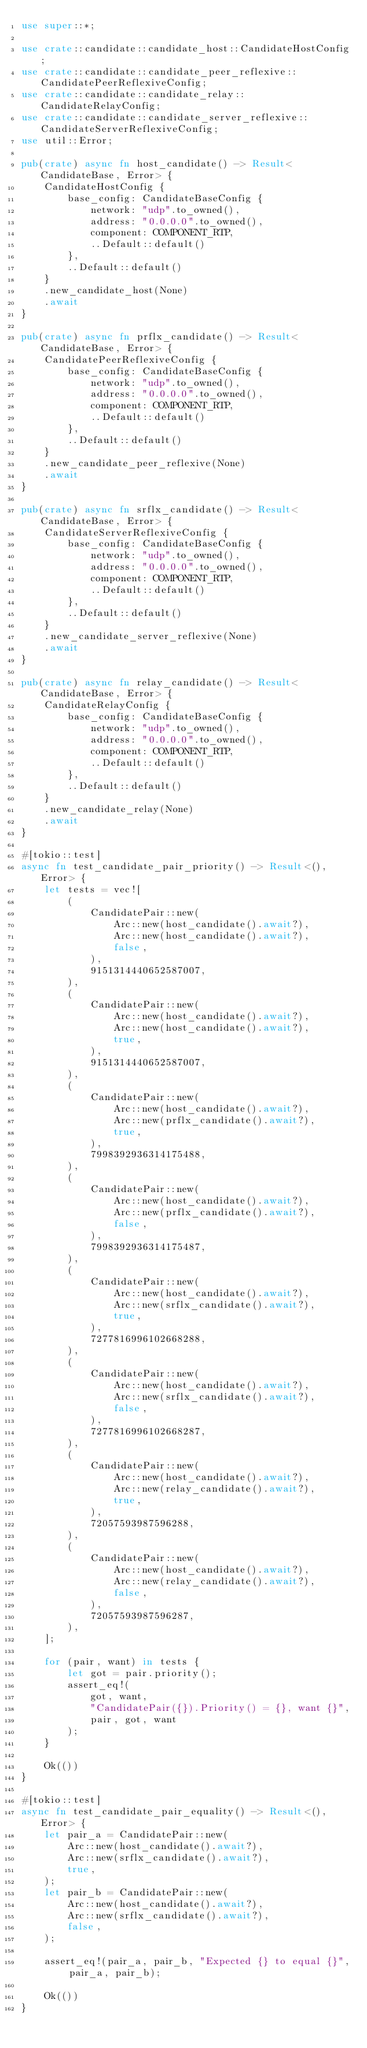<code> <loc_0><loc_0><loc_500><loc_500><_Rust_>use super::*;

use crate::candidate::candidate_host::CandidateHostConfig;
use crate::candidate::candidate_peer_reflexive::CandidatePeerReflexiveConfig;
use crate::candidate::candidate_relay::CandidateRelayConfig;
use crate::candidate::candidate_server_reflexive::CandidateServerReflexiveConfig;
use util::Error;

pub(crate) async fn host_candidate() -> Result<CandidateBase, Error> {
    CandidateHostConfig {
        base_config: CandidateBaseConfig {
            network: "udp".to_owned(),
            address: "0.0.0.0".to_owned(),
            component: COMPONENT_RTP,
            ..Default::default()
        },
        ..Default::default()
    }
    .new_candidate_host(None)
    .await
}

pub(crate) async fn prflx_candidate() -> Result<CandidateBase, Error> {
    CandidatePeerReflexiveConfig {
        base_config: CandidateBaseConfig {
            network: "udp".to_owned(),
            address: "0.0.0.0".to_owned(),
            component: COMPONENT_RTP,
            ..Default::default()
        },
        ..Default::default()
    }
    .new_candidate_peer_reflexive(None)
    .await
}

pub(crate) async fn srflx_candidate() -> Result<CandidateBase, Error> {
    CandidateServerReflexiveConfig {
        base_config: CandidateBaseConfig {
            network: "udp".to_owned(),
            address: "0.0.0.0".to_owned(),
            component: COMPONENT_RTP,
            ..Default::default()
        },
        ..Default::default()
    }
    .new_candidate_server_reflexive(None)
    .await
}

pub(crate) async fn relay_candidate() -> Result<CandidateBase, Error> {
    CandidateRelayConfig {
        base_config: CandidateBaseConfig {
            network: "udp".to_owned(),
            address: "0.0.0.0".to_owned(),
            component: COMPONENT_RTP,
            ..Default::default()
        },
        ..Default::default()
    }
    .new_candidate_relay(None)
    .await
}

#[tokio::test]
async fn test_candidate_pair_priority() -> Result<(), Error> {
    let tests = vec![
        (
            CandidatePair::new(
                Arc::new(host_candidate().await?),
                Arc::new(host_candidate().await?),
                false,
            ),
            9151314440652587007,
        ),
        (
            CandidatePair::new(
                Arc::new(host_candidate().await?),
                Arc::new(host_candidate().await?),
                true,
            ),
            9151314440652587007,
        ),
        (
            CandidatePair::new(
                Arc::new(host_candidate().await?),
                Arc::new(prflx_candidate().await?),
                true,
            ),
            7998392936314175488,
        ),
        (
            CandidatePair::new(
                Arc::new(host_candidate().await?),
                Arc::new(prflx_candidate().await?),
                false,
            ),
            7998392936314175487,
        ),
        (
            CandidatePair::new(
                Arc::new(host_candidate().await?),
                Arc::new(srflx_candidate().await?),
                true,
            ),
            7277816996102668288,
        ),
        (
            CandidatePair::new(
                Arc::new(host_candidate().await?),
                Arc::new(srflx_candidate().await?),
                false,
            ),
            7277816996102668287,
        ),
        (
            CandidatePair::new(
                Arc::new(host_candidate().await?),
                Arc::new(relay_candidate().await?),
                true,
            ),
            72057593987596288,
        ),
        (
            CandidatePair::new(
                Arc::new(host_candidate().await?),
                Arc::new(relay_candidate().await?),
                false,
            ),
            72057593987596287,
        ),
    ];

    for (pair, want) in tests {
        let got = pair.priority();
        assert_eq!(
            got, want,
            "CandidatePair({}).Priority() = {}, want {}",
            pair, got, want
        );
    }

    Ok(())
}

#[tokio::test]
async fn test_candidate_pair_equality() -> Result<(), Error> {
    let pair_a = CandidatePair::new(
        Arc::new(host_candidate().await?),
        Arc::new(srflx_candidate().await?),
        true,
    );
    let pair_b = CandidatePair::new(
        Arc::new(host_candidate().await?),
        Arc::new(srflx_candidate().await?),
        false,
    );

    assert_eq!(pair_a, pair_b, "Expected {} to equal {}", pair_a, pair_b);

    Ok(())
}
</code> 